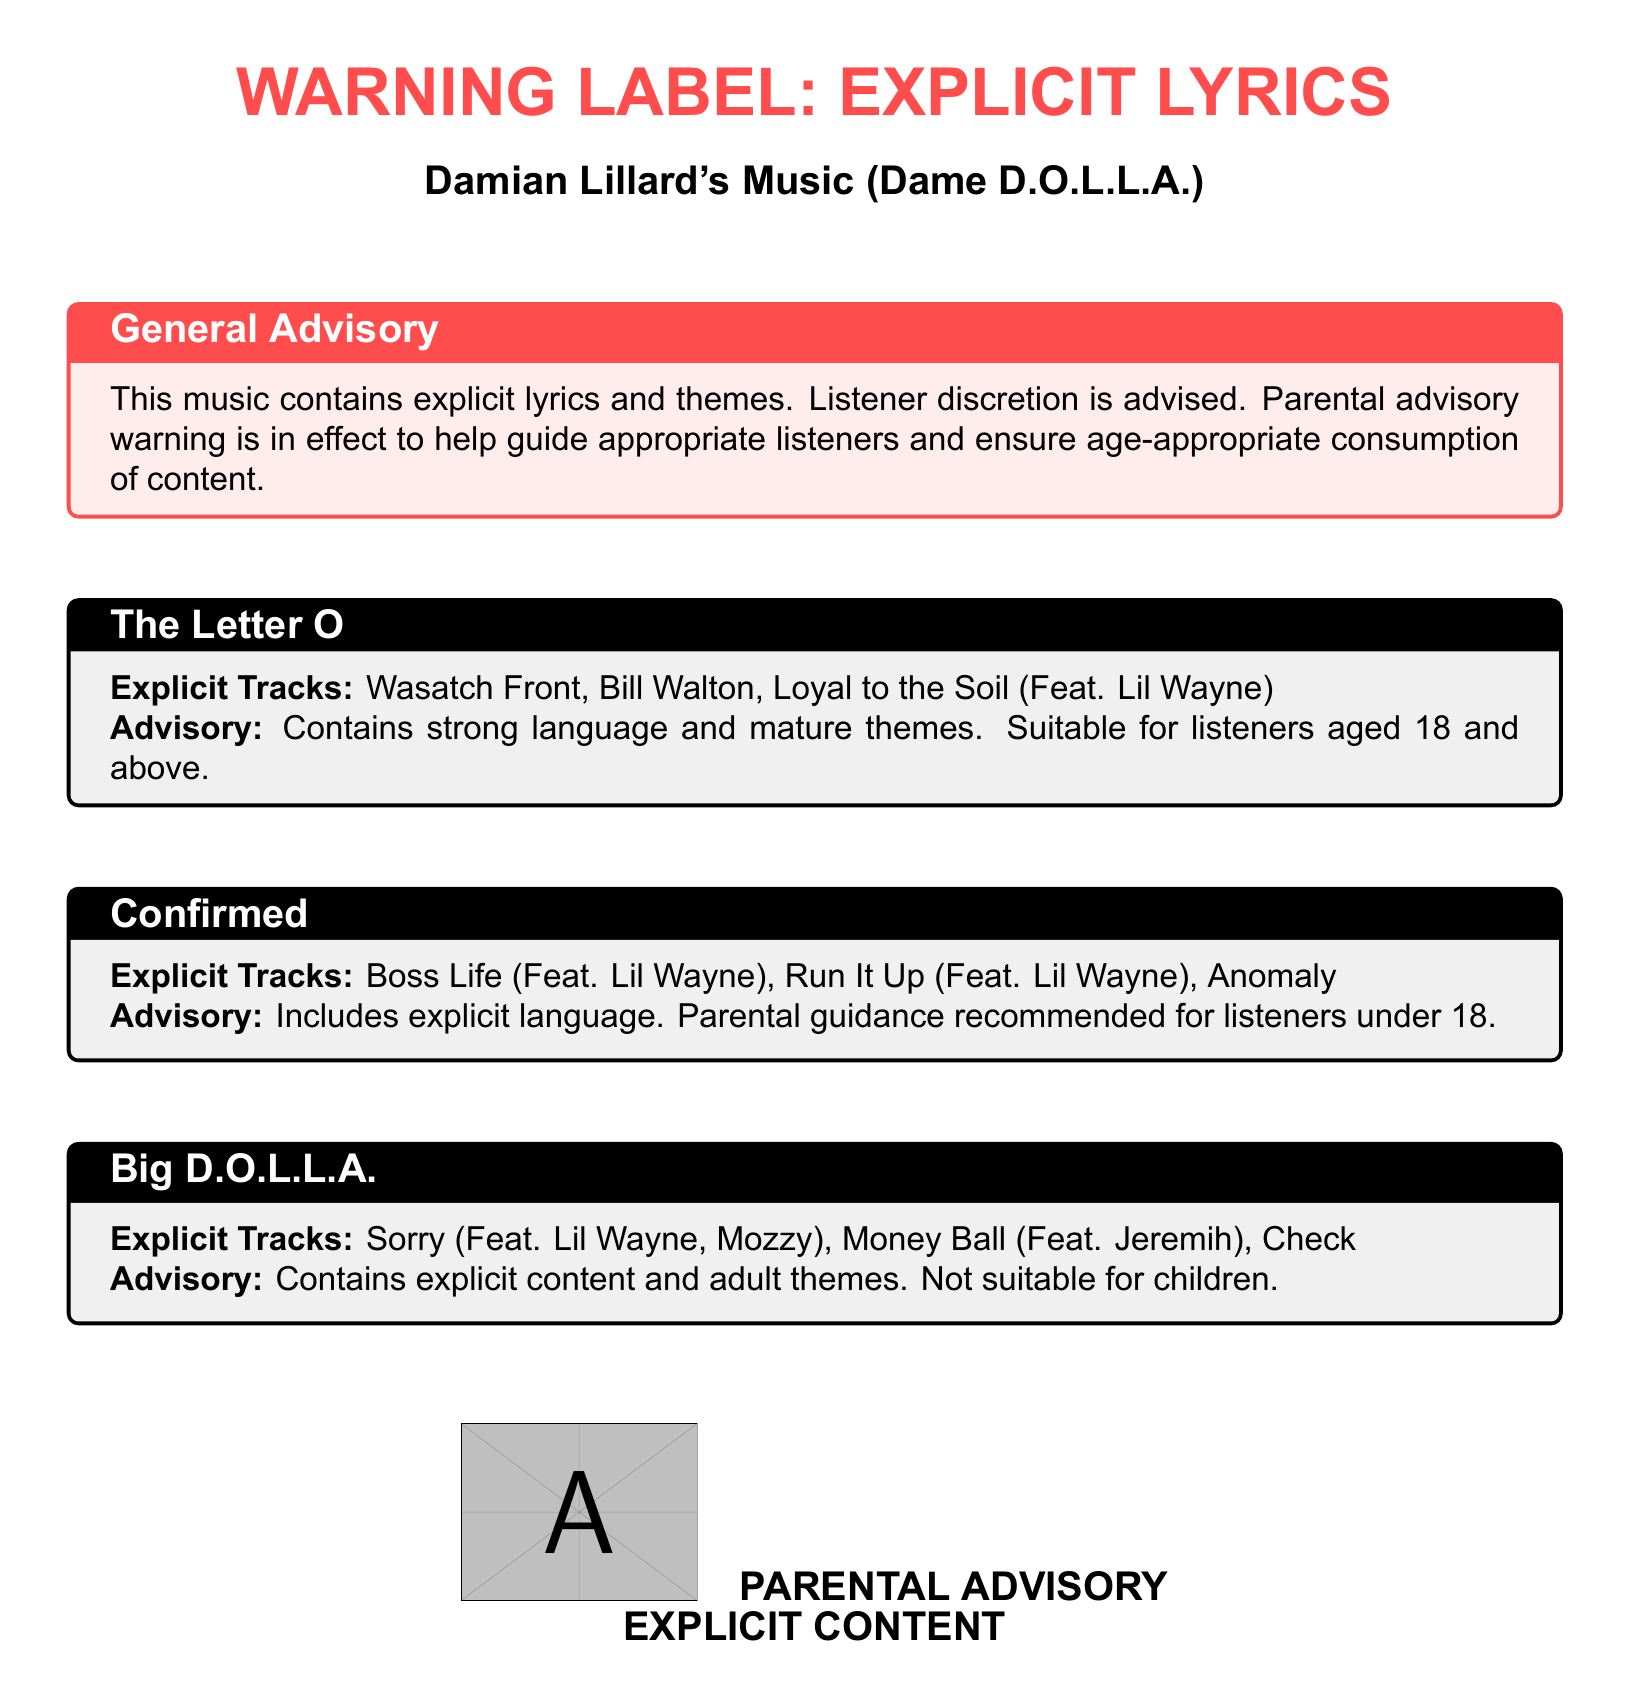What is the warning label about? The warning label states that the music contains explicit lyrics and themes, advising listener discretion.
Answer: Explicit lyrics and themes What is the parental advisory age recommendation for "The Letter O"? The advisory specifies that "The Letter O" is suitable for listeners aged 18 and above due to strong language and mature themes.
Answer: 18 and above Which explicit track features Lil Wayne in the album "Confirmed"? "Boss Life" features Lil Wayne and is listed as an explicit track in the album "Confirmed."
Answer: Boss Life How many explicit tracks are listed in "Big D.O.L.L.A."? The document lists three explicit tracks under the "Big D.O.L.L.A." album title.
Answer: Three What type of content does the album "Confirmed" include? The album "Confirmed" includes explicit language, requiring parental guidance for listeners under 18.
Answer: Explicit language What should listeners do according to the general advisory? The general advisory recommends listener discretion for content that contains explicit lyrics and themes.
Answer: Listener discretion advised Which track in "The Letter O" is explicitly noted? "Loyal to the Soil" is explicitly noted as a track featuring Lil Wayne in "The Letter O."
Answer: Loyal to the Soil What explicit content warning is associated with "Big D.O.L.L.A."? The album "Big D.O.L.L.A." is noted for containing explicit content and adult themes.
Answer: Explicit content and adult themes 